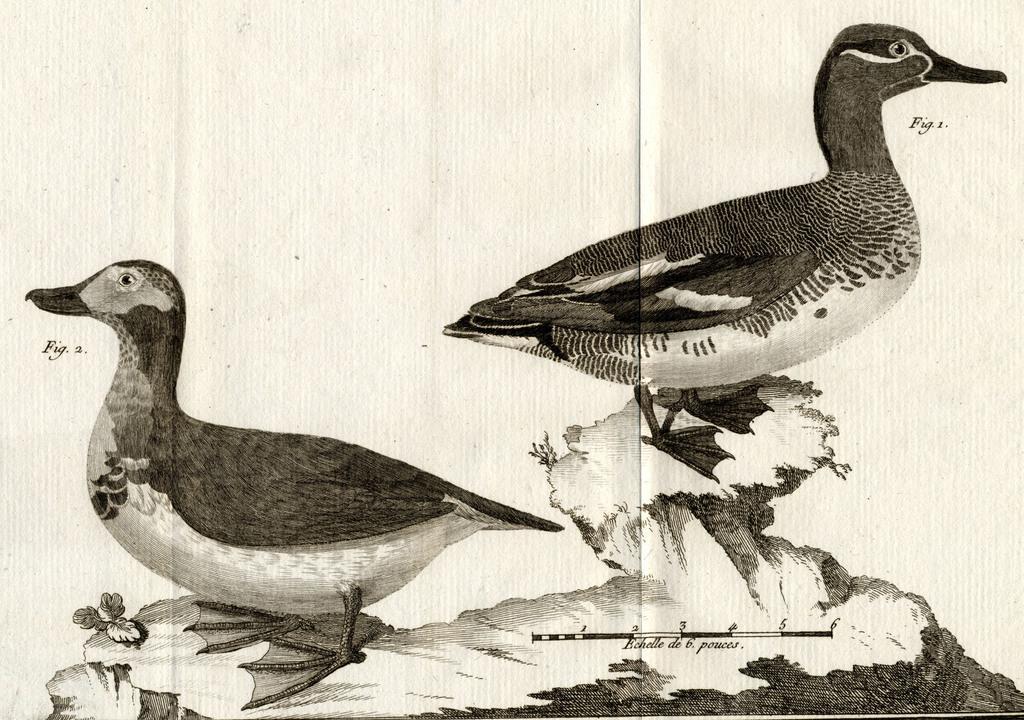Can you describe this image briefly? In this picture I can observe a sketch of two ducks. The sketch is in black color. This sketch was drawn on the paper. 